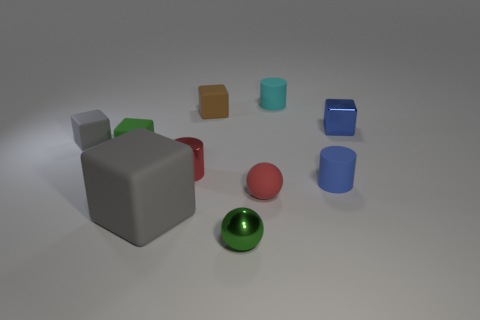Is the tiny rubber sphere the same color as the tiny shiny cylinder?
Your answer should be compact. Yes. What number of objects are either small cylinders that are on the right side of the red shiny cylinder or green metallic balls?
Your answer should be very brief. 3. There is a rubber cylinder behind the gray matte thing behind the gray thing in front of the small blue rubber cylinder; what color is it?
Ensure brevity in your answer.  Cyan. What color is the sphere that is the same material as the big thing?
Your response must be concise. Red. How many green objects have the same material as the blue block?
Your response must be concise. 1. Does the rubber cylinder that is behind the brown object have the same size as the large block?
Offer a terse response. No. What color is the other ball that is the same size as the green metallic ball?
Ensure brevity in your answer.  Red. There is a matte ball; how many small objects are in front of it?
Your response must be concise. 1. Is there a gray cylinder?
Provide a succinct answer. No. How big is the rubber cylinder behind the gray rubber object that is behind the gray matte object that is to the right of the tiny gray rubber thing?
Your answer should be compact. Small. 